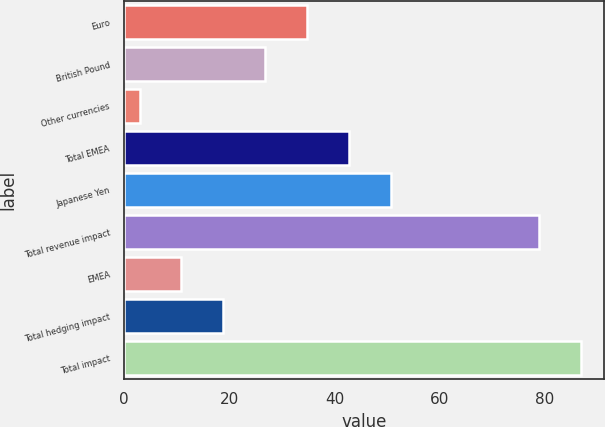Convert chart to OTSL. <chart><loc_0><loc_0><loc_500><loc_500><bar_chart><fcel>Euro<fcel>British Pound<fcel>Other currencies<fcel>Total EMEA<fcel>Japanese Yen<fcel>Total revenue impact<fcel>EMEA<fcel>Total hedging impact<fcel>Total impact<nl><fcel>34.82<fcel>26.84<fcel>2.9<fcel>42.8<fcel>50.78<fcel>78.9<fcel>10.88<fcel>18.86<fcel>86.88<nl></chart> 